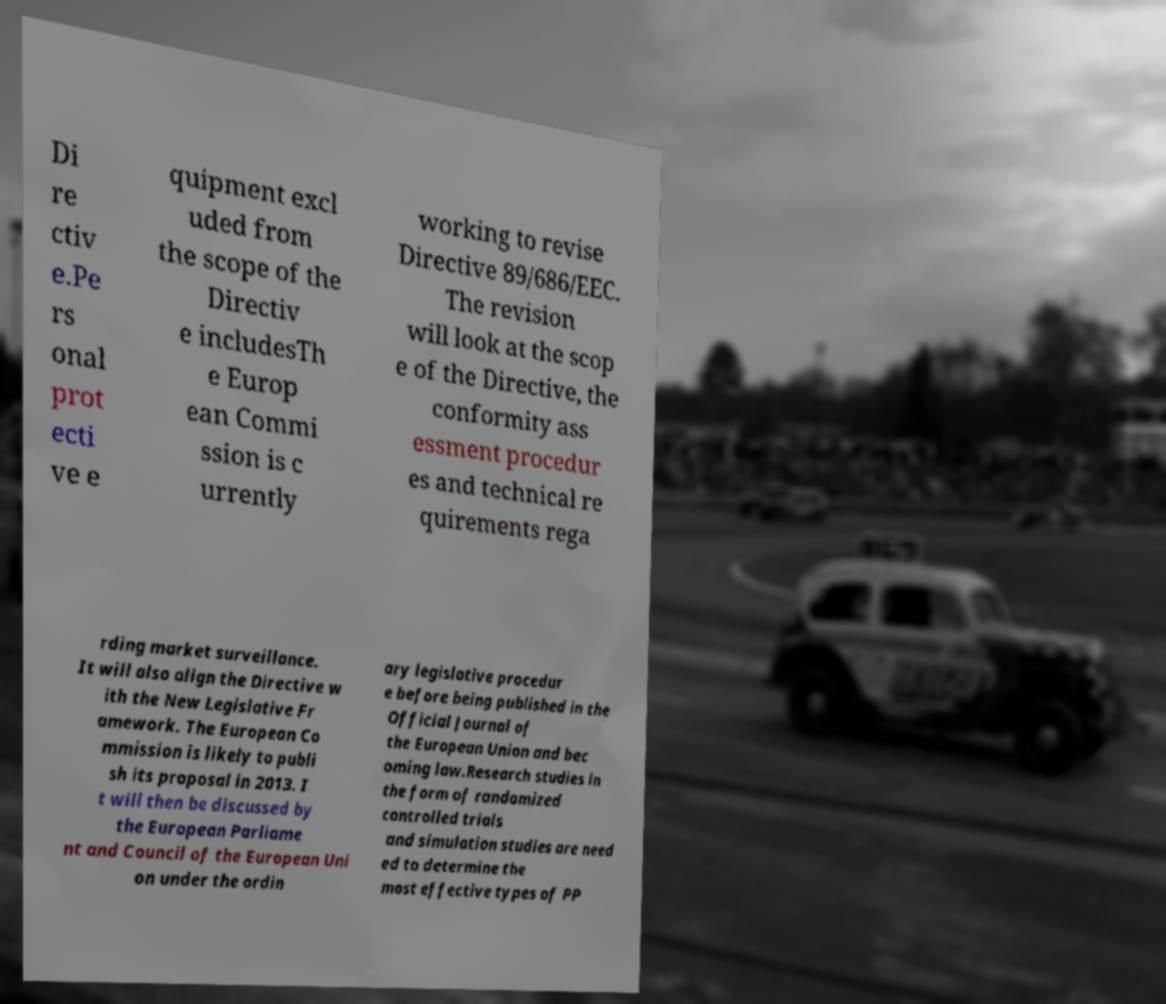Please identify and transcribe the text found in this image. Di re ctiv e.Pe rs onal prot ecti ve e quipment excl uded from the scope of the Directiv e includesTh e Europ ean Commi ssion is c urrently working to revise Directive 89/686/EEC. The revision will look at the scop e of the Directive, the conformity ass essment procedur es and technical re quirements rega rding market surveillance. It will also align the Directive w ith the New Legislative Fr amework. The European Co mmission is likely to publi sh its proposal in 2013. I t will then be discussed by the European Parliame nt and Council of the European Uni on under the ordin ary legislative procedur e before being published in the Official Journal of the European Union and bec oming law.Research studies in the form of randomized controlled trials and simulation studies are need ed to determine the most effective types of PP 